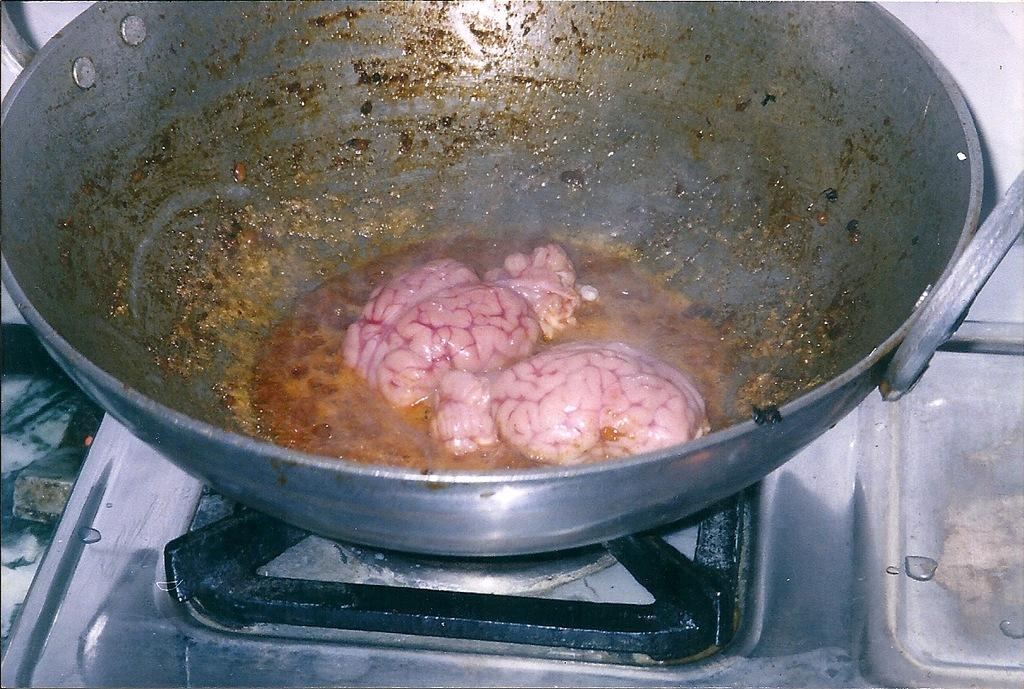What type of food is depicted in the image? The food contains a brain in the image. How is the food being contained or held? The food is in a vessel. Where is the vessel with the food placed? The vessel is placed on a stove. What type of furniture is visible in the image? There is no furniture visible in the image; it only shows food in a vessel on a stove. 